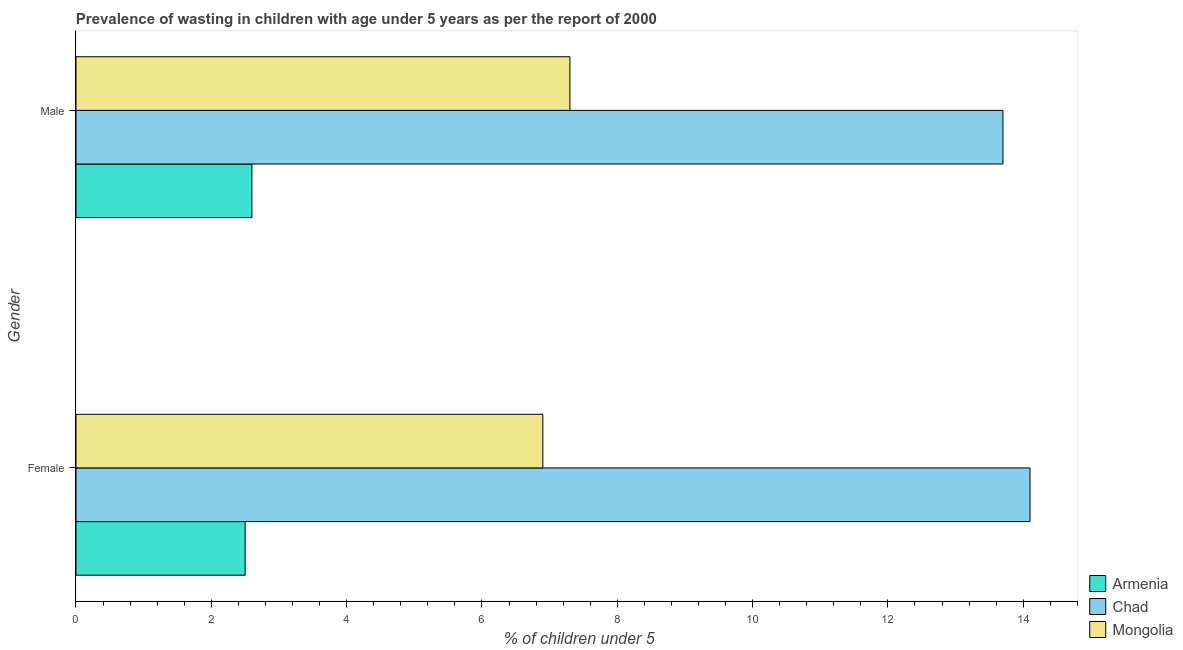How many bars are there on the 1st tick from the top?
Make the answer very short. 3. What is the percentage of undernourished male children in Mongolia?
Make the answer very short. 7.3. Across all countries, what is the maximum percentage of undernourished female children?
Make the answer very short. 14.1. Across all countries, what is the minimum percentage of undernourished male children?
Provide a succinct answer. 2.6. In which country was the percentage of undernourished male children maximum?
Your answer should be compact. Chad. In which country was the percentage of undernourished female children minimum?
Provide a short and direct response. Armenia. What is the total percentage of undernourished male children in the graph?
Ensure brevity in your answer.  23.6. What is the difference between the percentage of undernourished female children in Mongolia and that in Chad?
Offer a terse response. -7.2. What is the difference between the percentage of undernourished male children in Armenia and the percentage of undernourished female children in Chad?
Provide a short and direct response. -11.5. What is the average percentage of undernourished male children per country?
Provide a short and direct response. 7.87. What is the difference between the percentage of undernourished female children and percentage of undernourished male children in Mongolia?
Keep it short and to the point. -0.4. What is the ratio of the percentage of undernourished male children in Chad to that in Mongolia?
Offer a very short reply. 1.88. Is the percentage of undernourished male children in Armenia less than that in Chad?
Provide a short and direct response. Yes. What does the 3rd bar from the top in Female represents?
Offer a very short reply. Armenia. What does the 3rd bar from the bottom in Female represents?
Offer a terse response. Mongolia. How many bars are there?
Keep it short and to the point. 6. Are all the bars in the graph horizontal?
Your answer should be compact. Yes. Does the graph contain grids?
Make the answer very short. No. Where does the legend appear in the graph?
Ensure brevity in your answer.  Bottom right. What is the title of the graph?
Keep it short and to the point. Prevalence of wasting in children with age under 5 years as per the report of 2000. What is the label or title of the X-axis?
Your answer should be very brief.  % of children under 5. What is the label or title of the Y-axis?
Your answer should be compact. Gender. What is the  % of children under 5 in Chad in Female?
Your answer should be very brief. 14.1. What is the  % of children under 5 of Mongolia in Female?
Provide a succinct answer. 6.9. What is the  % of children under 5 of Armenia in Male?
Offer a very short reply. 2.6. What is the  % of children under 5 of Chad in Male?
Your answer should be very brief. 13.7. What is the  % of children under 5 in Mongolia in Male?
Your response must be concise. 7.3. Across all Gender, what is the maximum  % of children under 5 in Armenia?
Your answer should be very brief. 2.6. Across all Gender, what is the maximum  % of children under 5 of Chad?
Keep it short and to the point. 14.1. Across all Gender, what is the maximum  % of children under 5 of Mongolia?
Your answer should be very brief. 7.3. Across all Gender, what is the minimum  % of children under 5 of Armenia?
Make the answer very short. 2.5. Across all Gender, what is the minimum  % of children under 5 of Chad?
Your answer should be very brief. 13.7. Across all Gender, what is the minimum  % of children under 5 in Mongolia?
Make the answer very short. 6.9. What is the total  % of children under 5 in Chad in the graph?
Give a very brief answer. 27.8. What is the difference between the  % of children under 5 of Armenia in Female and that in Male?
Make the answer very short. -0.1. What is the difference between the  % of children under 5 of Chad in Female and that in Male?
Offer a terse response. 0.4. What is the difference between the  % of children under 5 of Armenia in Female and the  % of children under 5 of Chad in Male?
Give a very brief answer. -11.2. What is the average  % of children under 5 in Armenia per Gender?
Your response must be concise. 2.55. What is the difference between the  % of children under 5 of Armenia and  % of children under 5 of Chad in Female?
Give a very brief answer. -11.6. What is the difference between the  % of children under 5 of Chad and  % of children under 5 of Mongolia in Female?
Provide a short and direct response. 7.2. What is the difference between the  % of children under 5 of Armenia and  % of children under 5 of Mongolia in Male?
Offer a terse response. -4.7. What is the difference between the  % of children under 5 in Chad and  % of children under 5 in Mongolia in Male?
Provide a succinct answer. 6.4. What is the ratio of the  % of children under 5 in Armenia in Female to that in Male?
Make the answer very short. 0.96. What is the ratio of the  % of children under 5 of Chad in Female to that in Male?
Offer a very short reply. 1.03. What is the ratio of the  % of children under 5 in Mongolia in Female to that in Male?
Keep it short and to the point. 0.95. What is the difference between the highest and the second highest  % of children under 5 in Mongolia?
Your response must be concise. 0.4. What is the difference between the highest and the lowest  % of children under 5 in Mongolia?
Provide a succinct answer. 0.4. 